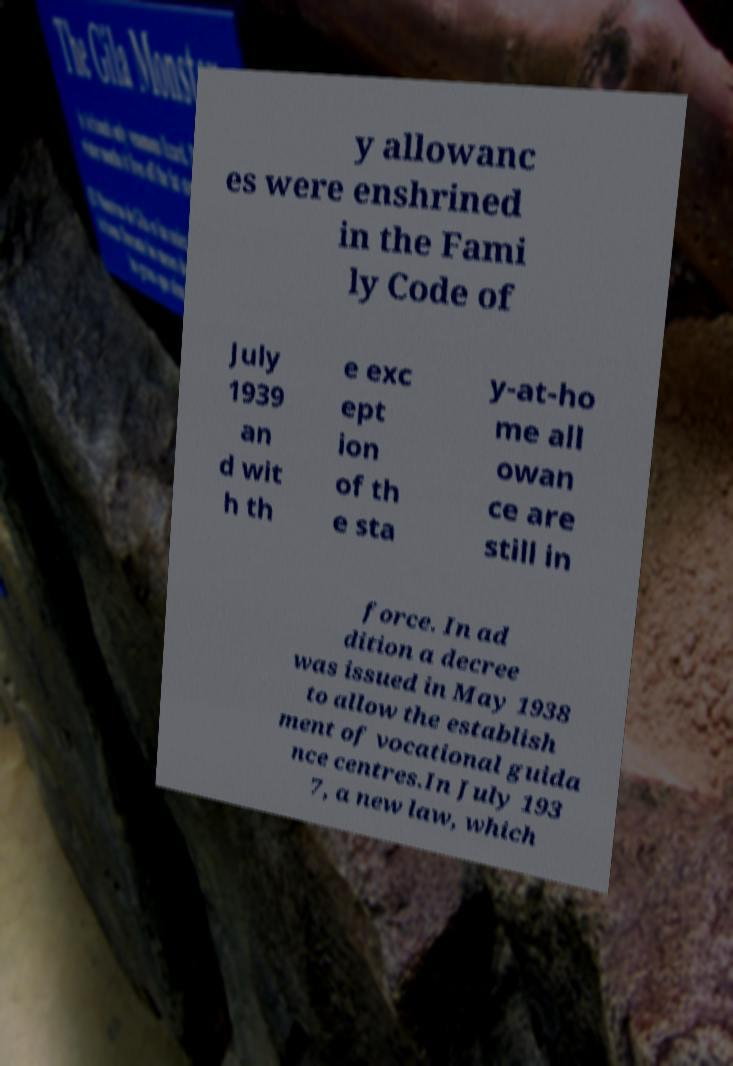There's text embedded in this image that I need extracted. Can you transcribe it verbatim? y allowanc es were enshrined in the Fami ly Code of July 1939 an d wit h th e exc ept ion of th e sta y-at-ho me all owan ce are still in force. In ad dition a decree was issued in May 1938 to allow the establish ment of vocational guida nce centres.In July 193 7, a new law, which 